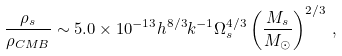Convert formula to latex. <formula><loc_0><loc_0><loc_500><loc_500>\frac { \rho _ { s } } { \rho _ { C M B } } \sim 5 . 0 \times 1 0 ^ { - 1 3 } h ^ { 8 / 3 } k ^ { - 1 } \Omega _ { s } ^ { 4 / 3 } \left ( \frac { M _ { s } } { M _ { \odot } } \right ) ^ { 2 / 3 } \, ,</formula> 